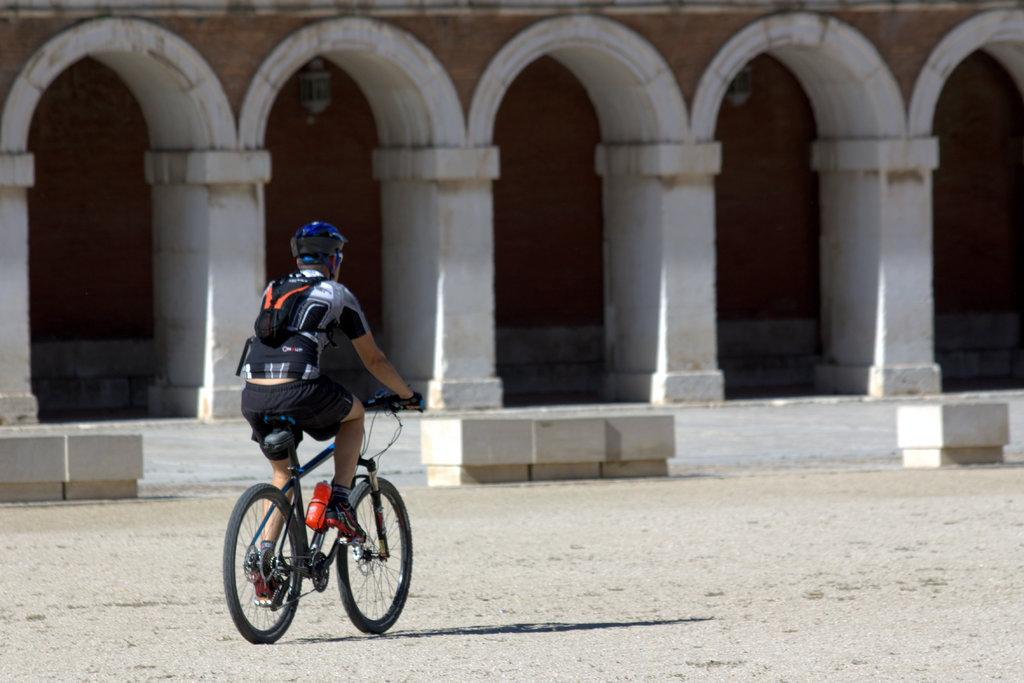What is the person in the image doing? There is a person riding a bicycle on the road in the image. What type of structures can be seen in the image? Stone platforms, pillars, arches, and walls are visible in the image. How many pizzas are being held by the person riding the bicycle in the image? There are no pizzas present in the image; the person is riding a bicycle on the road. What type of pot is visible in the image? There is no pot present in the image. 